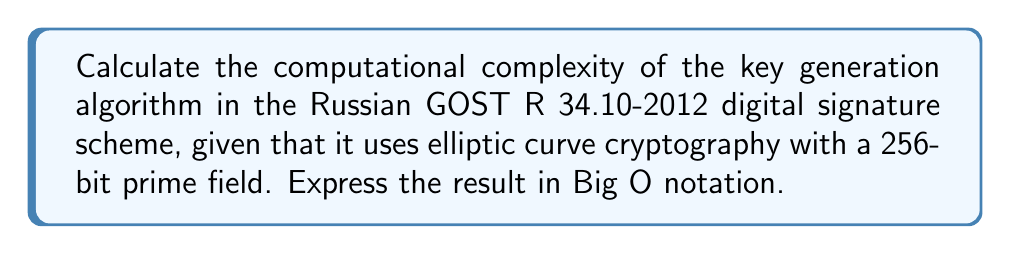Provide a solution to this math problem. To evaluate the computational complexity of the GOST R 34.10-2012 key generation algorithm, we need to consider the following steps:

1. The algorithm uses elliptic curve cryptography (ECC) over a prime field of 256 bits.

2. Key generation in ECC involves the following main operations:
   a) Generating a random integer $d$ (private key) in the range $[1, n-1]$, where $n$ is the order of the base point.
   b) Computing the public key $Q = dG$, where $G$ is the base point of the curve.

3. The complexity of generating a random integer $d$ is $O(1)$, as it's a constant-time operation.

4. The main computational cost comes from the scalar multiplication $Q = dG$. This operation is typically performed using the double-and-add algorithm.

5. The double-and-add algorithm has a complexity of $O(\log d)$ point doublings and $O(\log d)$ point additions in the worst case.

6. Since $d$ is a 256-bit integer, $\log d \approx 256$.

7. Both point doubling and point addition operations in ECC have a complexity of $O(1)$ for fixed-size fields.

8. Therefore, the overall complexity of the scalar multiplication is:
   $O(\log d) \cdot O(1) = O(\log d) = O(\log n)$, where $n$ is the order of the base point.

9. Since the field size is fixed at 256 bits, we can consider $\log n$ as a constant.

Thus, the computational complexity of the key generation algorithm in GOST R 34.10-2012 is $O(1)$ for a fixed 256-bit prime field.
Answer: $O(1)$ 